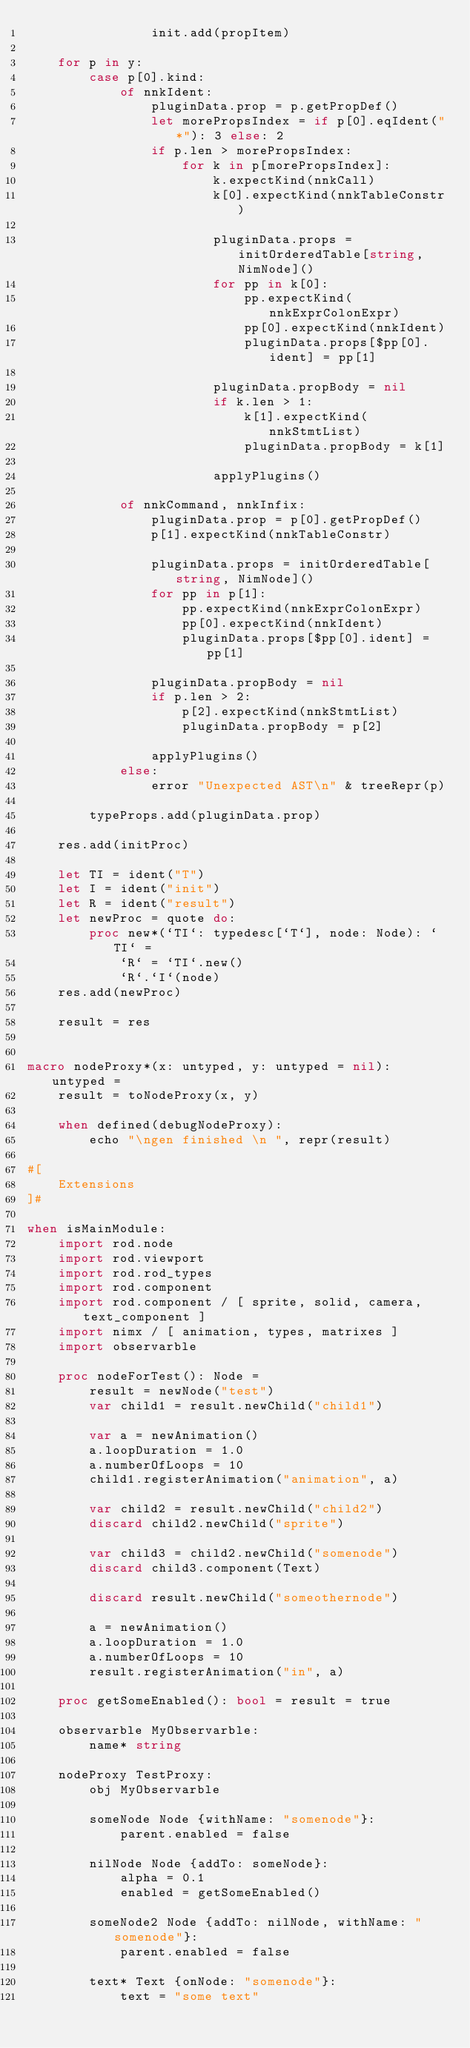Convert code to text. <code><loc_0><loc_0><loc_500><loc_500><_Nim_>                init.add(propItem)

    for p in y:
        case p[0].kind:
            of nnkIdent:
                pluginData.prop = p.getPropDef()
                let morePropsIndex = if p[0].eqIdent("*"): 3 else: 2
                if p.len > morePropsIndex:
                    for k in p[morePropsIndex]:
                        k.expectKind(nnkCall)
                        k[0].expectKind(nnkTableConstr)
                        
                        pluginData.props = initOrderedTable[string, NimNode]()
                        for pp in k[0]:
                            pp.expectKind(nnkExprColonExpr)
                            pp[0].expectKind(nnkIdent)
                            pluginData.props[$pp[0].ident] = pp[1]
                        
                        pluginData.propBody = nil
                        if k.len > 1:
                            k[1].expectKind(nnkStmtList)
                            pluginData.propBody = k[1]

                        applyPlugins()

            of nnkCommand, nnkInfix:
                pluginData.prop = p[0].getPropDef()
                p[1].expectKind(nnkTableConstr)

                pluginData.props = initOrderedTable[string, NimNode]()
                for pp in p[1]:
                    pp.expectKind(nnkExprColonExpr)
                    pp[0].expectKind(nnkIdent)
                    pluginData.props[$pp[0].ident] = pp[1]
                
                pluginData.propBody = nil
                if p.len > 2:
                    p[2].expectKind(nnkStmtList)
                    pluginData.propBody = p[2]

                applyPlugins()
            else:
                error "Unexpected AST\n" & treeRepr(p)

        typeProps.add(pluginData.prop)

    res.add(initProc)
    
    let TI = ident("T")
    let I = ident("init")
    let R = ident("result")
    let newProc = quote do:
        proc new*(`TI`: typedesc[`T`], node: Node): `TI` =
            `R` = `TI`.new()
            `R`.`I`(node)
    res.add(newProc)

    result = res


macro nodeProxy*(x: untyped, y: untyped = nil): untyped =
    result = toNodeProxy(x, y)

    when defined(debugNodeProxy):
        echo "\ngen finished \n ", repr(result)

#[
    Extensions
]#

when isMainModule:
    import rod.node
    import rod.viewport
    import rod.rod_types
    import rod.component
    import rod.component / [ sprite, solid, camera, text_component ]
    import nimx / [ animation, types, matrixes ]
    import observarble

    proc nodeForTest(): Node =
        result = newNode("test")
        var child1 = result.newChild("child1")

        var a = newAnimation()
        a.loopDuration = 1.0
        a.numberOfLoops = 10
        child1.registerAnimation("animation", a)

        var child2 = result.newChild("child2")
        discard child2.newChild("sprite")

        var child3 = child2.newChild("somenode")
        discard child3.component(Text)

        discard result.newChild("someothernode")

        a = newAnimation()
        a.loopDuration = 1.0
        a.numberOfLoops = 10
        result.registerAnimation("in", a)

    proc getSomeEnabled(): bool = result = true
    
    observarble MyObservarble:
        name* string

    nodeProxy TestProxy:
        obj MyObservarble

        someNode Node {withName: "somenode"}:
            parent.enabled = false

        nilNode Node {addTo: someNode}:
            alpha = 0.1
            enabled = getSomeEnabled()

        someNode2 Node {addTo: nilNode, withName: "somenode"}:
            parent.enabled = false

        text* Text {onNode: "somenode"}:
            text = "some text"
</code> 